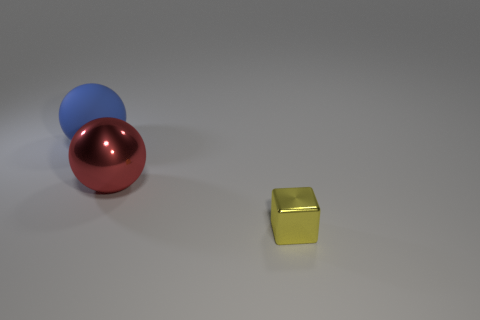There is a small shiny object; what shape is it?
Ensure brevity in your answer.  Cube. Are there fewer blue objects that are to the right of the red metal sphere than yellow things?
Ensure brevity in your answer.  Yes. Is there a red shiny thing of the same shape as the big rubber object?
Your answer should be very brief. Yes. The shiny object that is the same size as the blue sphere is what shape?
Provide a short and direct response. Sphere. How many objects are either small metal blocks or big red objects?
Ensure brevity in your answer.  2. Is there a cube?
Your answer should be very brief. Yes. Are there fewer yellow spheres than rubber balls?
Keep it short and to the point. Yes. Are there any red shiny objects that have the same size as the red ball?
Your answer should be very brief. No. There is a big rubber thing; does it have the same shape as the object in front of the red ball?
Provide a short and direct response. No. What number of blocks are metallic objects or rubber things?
Ensure brevity in your answer.  1. 